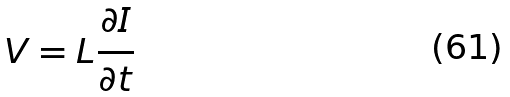Convert formula to latex. <formula><loc_0><loc_0><loc_500><loc_500>V = L \frac { \partial I } { \partial t }</formula> 